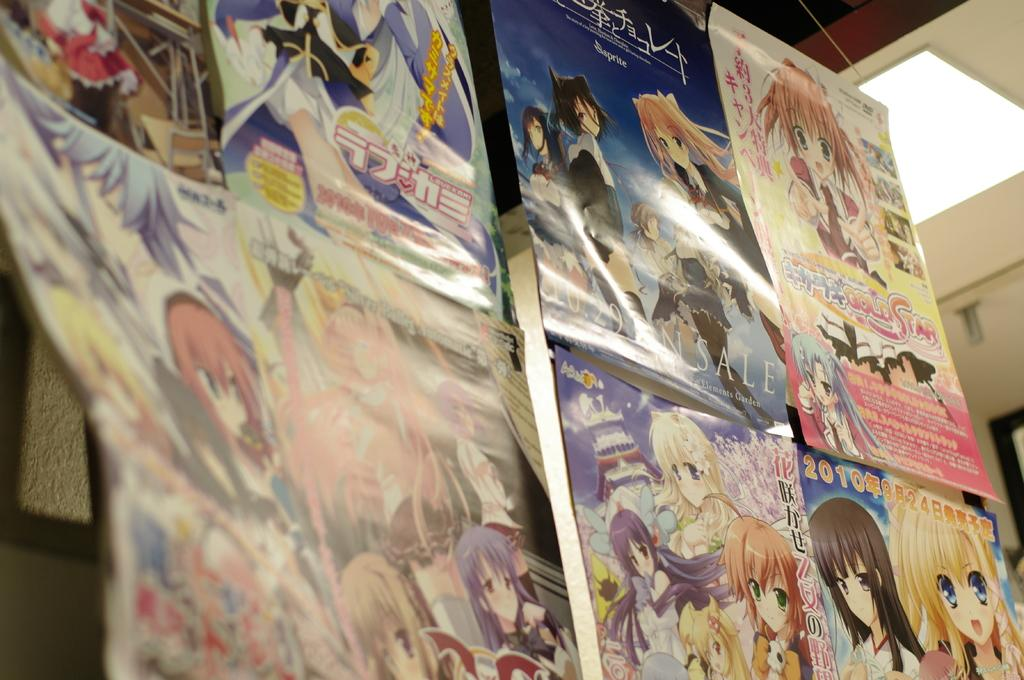<image>
Describe the image concisely. Anime posters on a wall with one from 2010. 